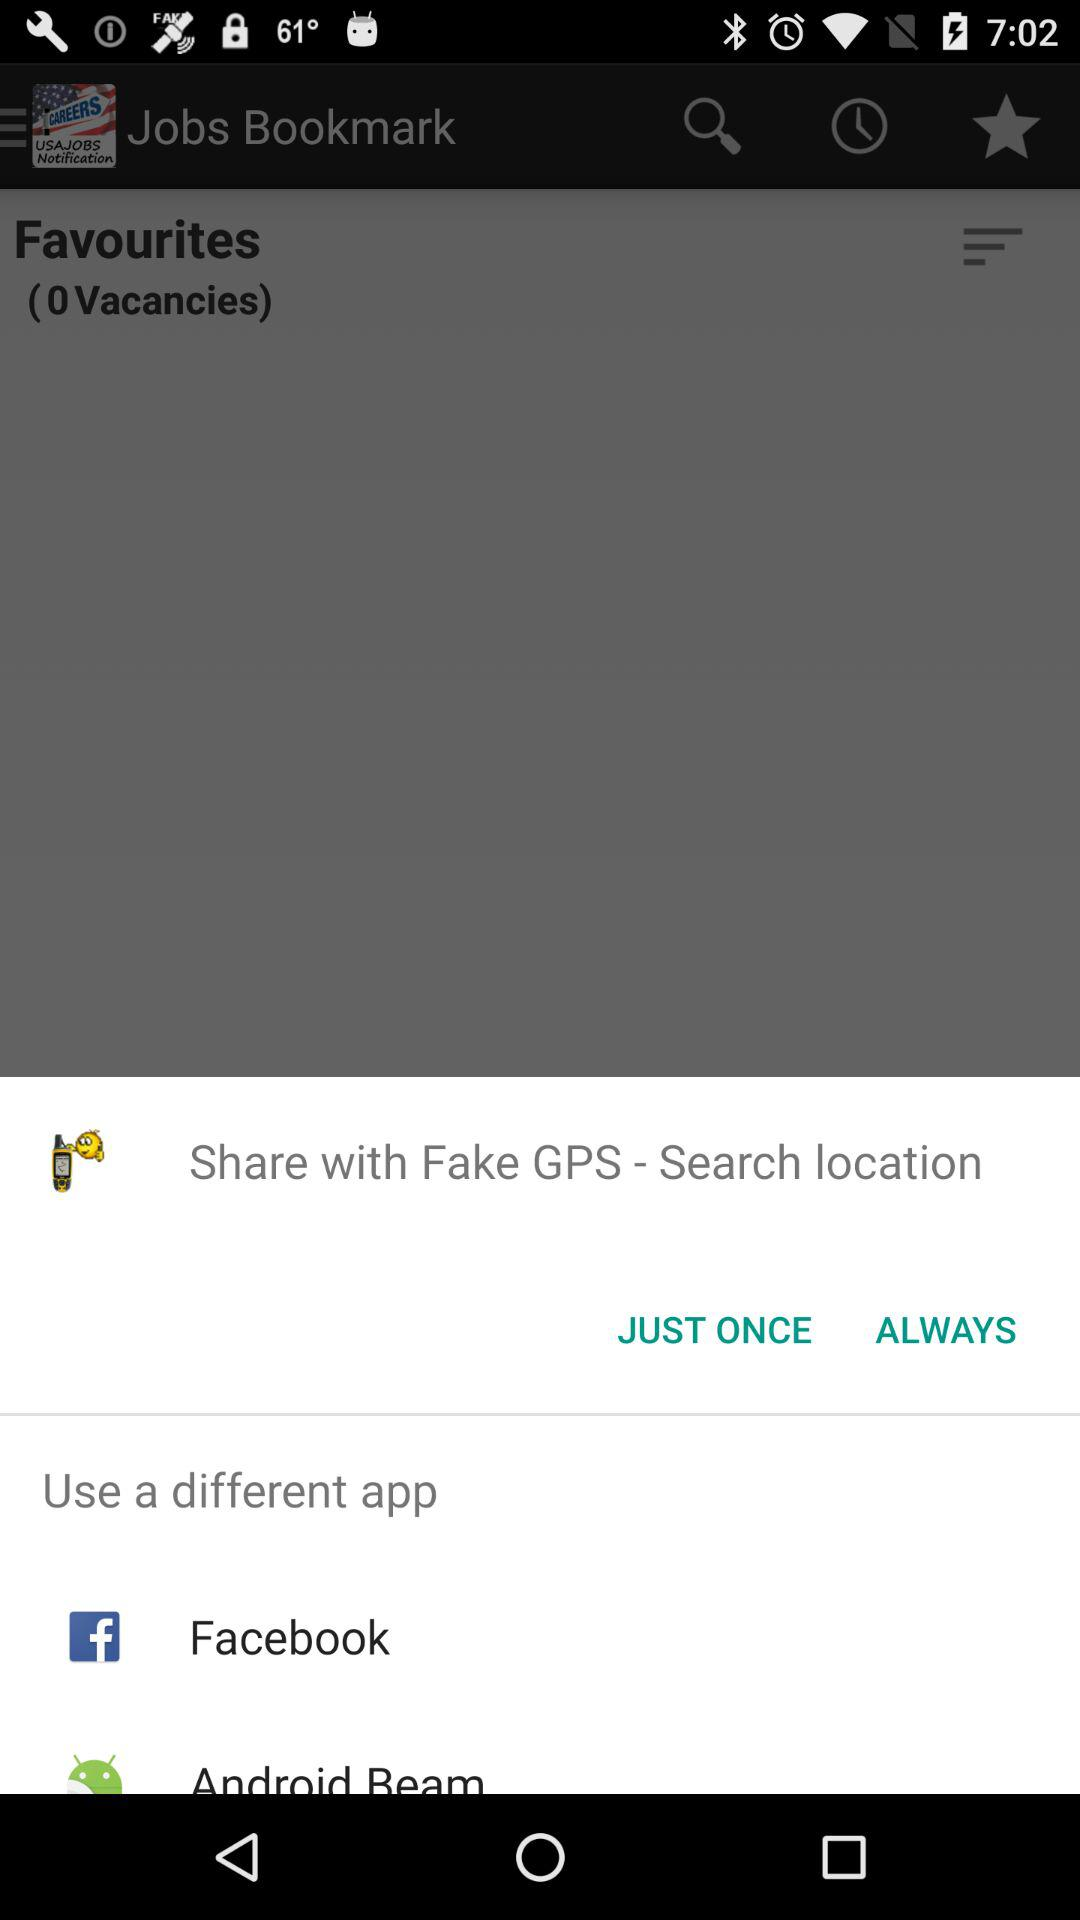How many more notifications are there than vacancies?
Answer the question using a single word or phrase. 1 